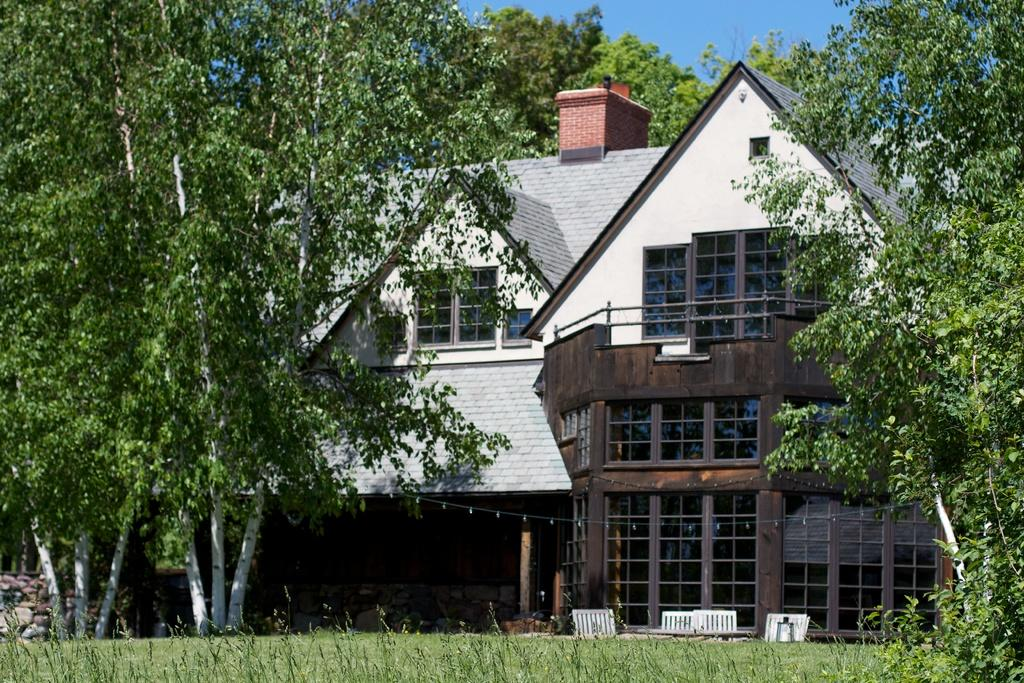What type of structure is visible in the image? There is a house in the image. What can be seen in the surroundings of the house? There are many trees and a grassy land in the image. What is the color of the sky in the image? The sky is clear blue in the image. Where is the daughter playing with a glass and sponge in the image? There is no daughter, glass, or sponge present in the image. 